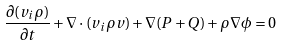<formula> <loc_0><loc_0><loc_500><loc_500>\frac { \partial ( v _ { i } \rho ) } { \partial t } + \nabla \cdot ( v _ { i } \rho { v } ) + \nabla ( P + Q ) + \rho \nabla \phi = 0</formula> 